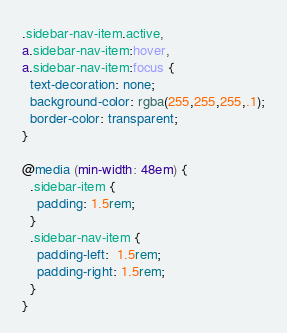Convert code to text. <code><loc_0><loc_0><loc_500><loc_500><_CSS_>.sidebar-nav-item.active,
a.sidebar-nav-item:hover,
a.sidebar-nav-item:focus {
  text-decoration: none;
  background-color: rgba(255,255,255,.1);
  border-color: transparent;
}

@media (min-width: 48em) {
  .sidebar-item {
    padding: 1.5rem;
  }
  .sidebar-nav-item {
    padding-left:  1.5rem;
    padding-right: 1.5rem;
  }
}
</code> 